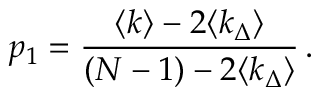Convert formula to latex. <formula><loc_0><loc_0><loc_500><loc_500>p _ { 1 } = \frac { \langle k \rangle - 2 \langle k _ { \Delta } \rangle } { ( N - 1 ) - 2 \langle k _ { \Delta } \rangle } \, .</formula> 